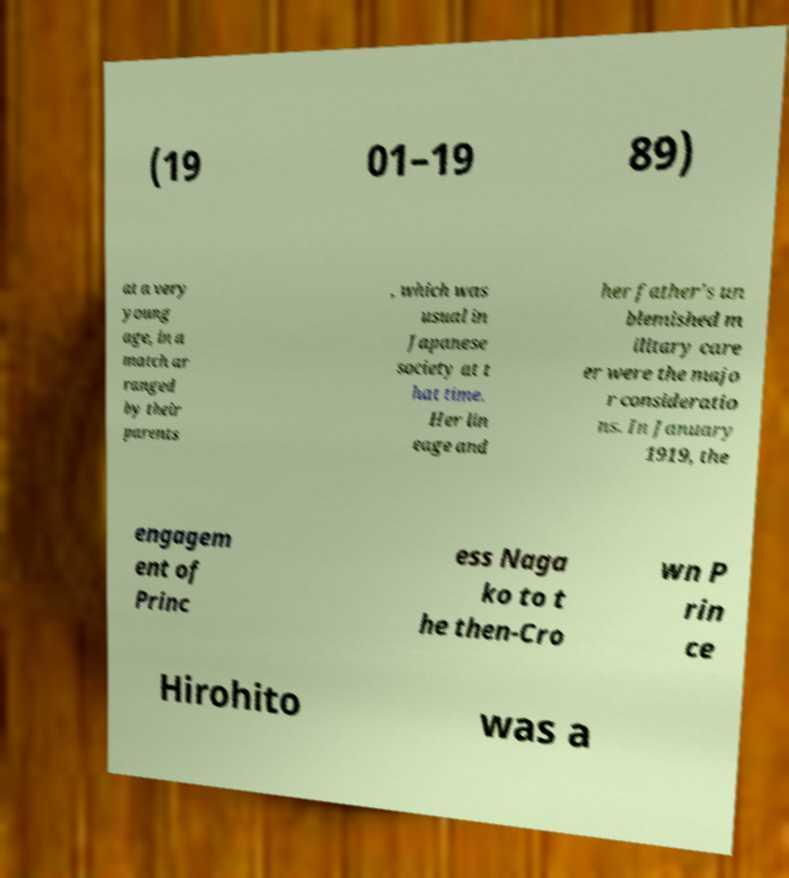For documentation purposes, I need the text within this image transcribed. Could you provide that? (19 01–19 89) at a very young age, in a match ar ranged by their parents , which was usual in Japanese society at t hat time. Her lin eage and her father's un blemished m ilitary care er were the majo r consideratio ns. In January 1919, the engagem ent of Princ ess Naga ko to t he then-Cro wn P rin ce Hirohito was a 